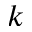<formula> <loc_0><loc_0><loc_500><loc_500>k</formula> 